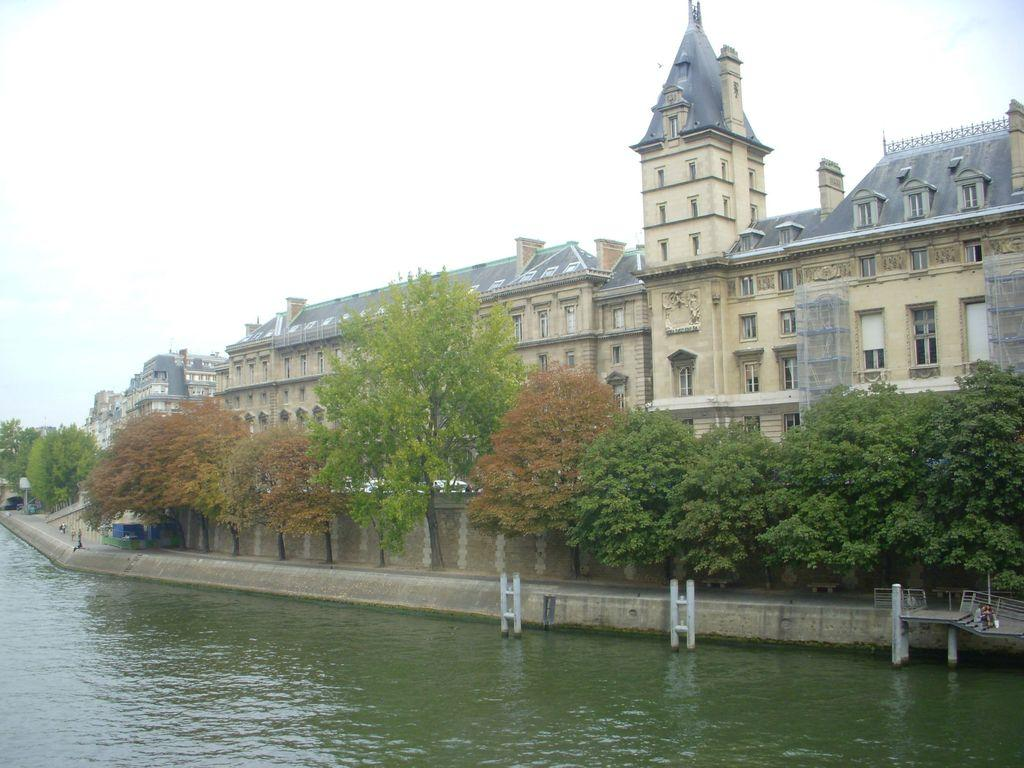What can be seen in the sky in the image? The sky is visible in the image. What type of structures are present in the image? There are buildings in the image. What architectural feature can be seen in the image? There are windows and a wall visible in the image. What natural elements are present in the image? There are trees and water visible in the image. What safety feature can be seen in the image? Railings are present in the image. Can you describe any unspecified objects in the image? There are unspecified objects in the image, but their details are not provided in the facts. How many representatives are present in the image? There is no mention of representatives in the image, so it cannot be determined from the facts. 